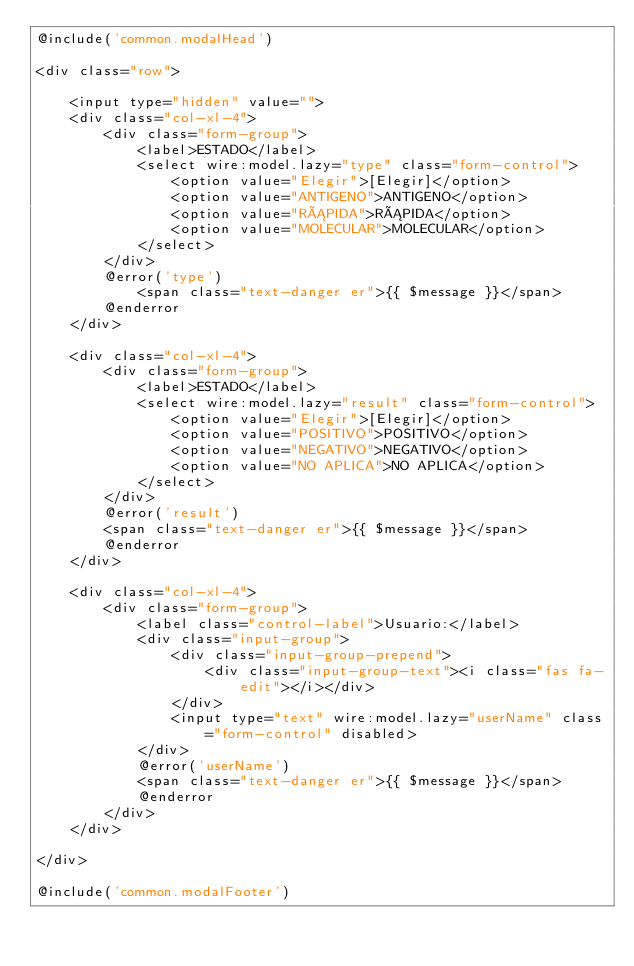Convert code to text. <code><loc_0><loc_0><loc_500><loc_500><_PHP_>@include('common.modalHead')

<div class="row">

    <input type="hidden" value="">
    <div class="col-xl-4">
        <div class="form-group">
            <label>ESTADO</label>
            <select wire:model.lazy="type" class="form-control">
                <option value="Elegir">[Elegir]</option>
                <option value="ANTIGENO">ANTIGENO</option>
                <option value="RÁPIDA">RÁPIDA</option>
                <option value="MOLECULAR">MOLECULAR</option>
            </select>
        </div>
        @error('type')
            <span class="text-danger er">{{ $message }}</span>
        @enderror
    </div>

    <div class="col-xl-4">
        <div class="form-group">
            <label>ESTADO</label>
            <select wire:model.lazy="result" class="form-control">
                <option value="Elegir">[Elegir]</option>
                <option value="POSITIVO">POSITIVO</option>
                <option value="NEGATIVO">NEGATIVO</option>
                <option value="NO APLICA">NO APLICA</option>
            </select>
        </div>
        @error('result')
        <span class="text-danger er">{{ $message }}</span>
        @enderror
    </div>

    <div class="col-xl-4">
        <div class="form-group">
            <label class="control-label">Usuario:</label>
            <div class="input-group">
                <div class="input-group-prepend">
                    <div class="input-group-text"><i class="fas fa-edit"></i></div>
                </div>
                <input type="text" wire:model.lazy="userName" class="form-control" disabled>
            </div>
            @error('userName')
            <span class="text-danger er">{{ $message }}</span>
            @enderror
        </div>
    </div>

</div>

@include('common.modalFooter')
</code> 